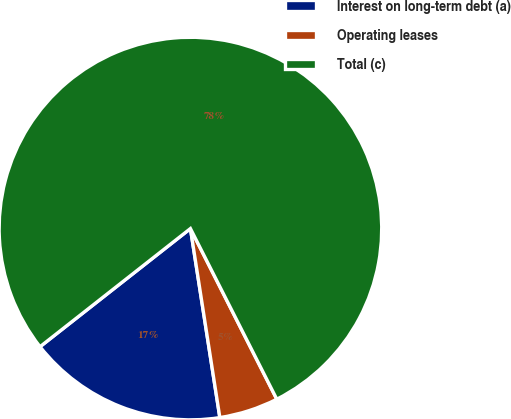Convert chart. <chart><loc_0><loc_0><loc_500><loc_500><pie_chart><fcel>Interest on long-term debt (a)<fcel>Operating leases<fcel>Total (c)<nl><fcel>16.86%<fcel>5.0%<fcel>78.14%<nl></chart> 